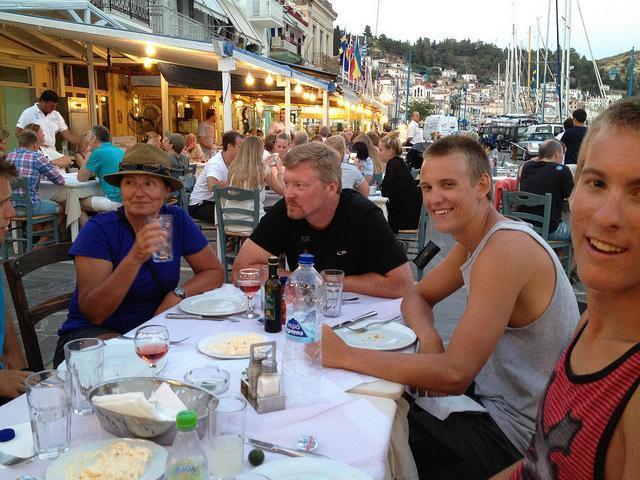How many people are in the picture?
Give a very brief answer. 9. How many cups can you see?
Give a very brief answer. 3. How many chairs are in the photo?
Give a very brief answer. 2. How many giraffes are in the picture?
Give a very brief answer. 0. 